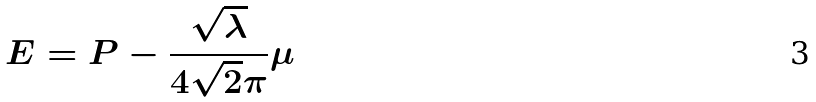Convert formula to latex. <formula><loc_0><loc_0><loc_500><loc_500>E = P - \frac { \sqrt { \lambda } } { 4 \sqrt { 2 } \pi } \mu</formula> 